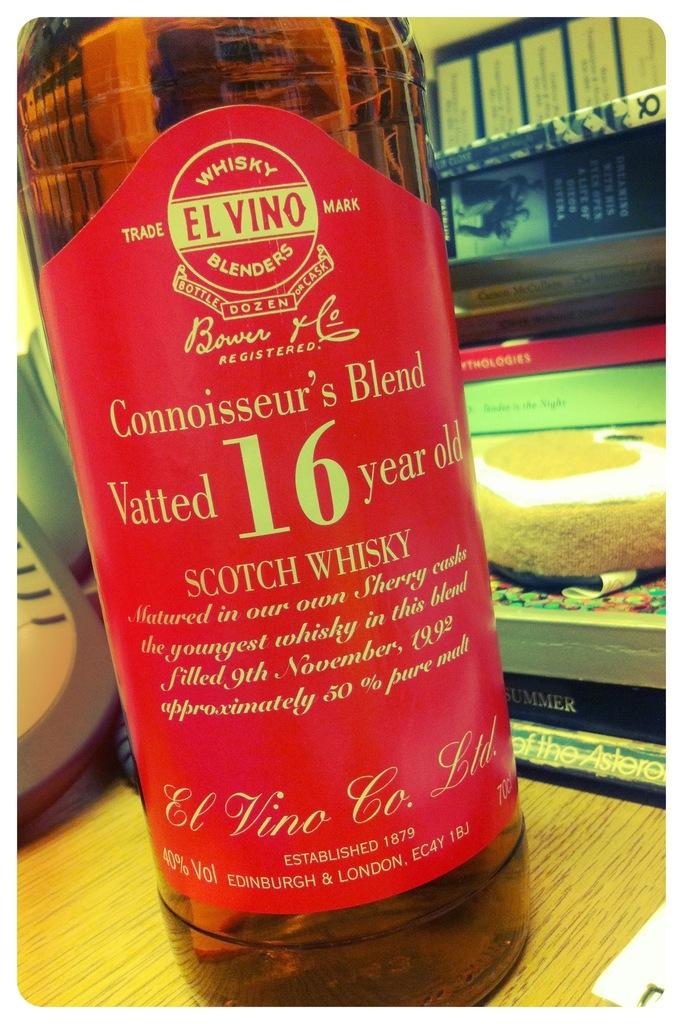What is the main object in the image? There is a wine bottle in the image. Where is the wine bottle located? The wine bottle is placed on a table. How many volleyballs are visible in the image? There are no volleyballs present in the image. 